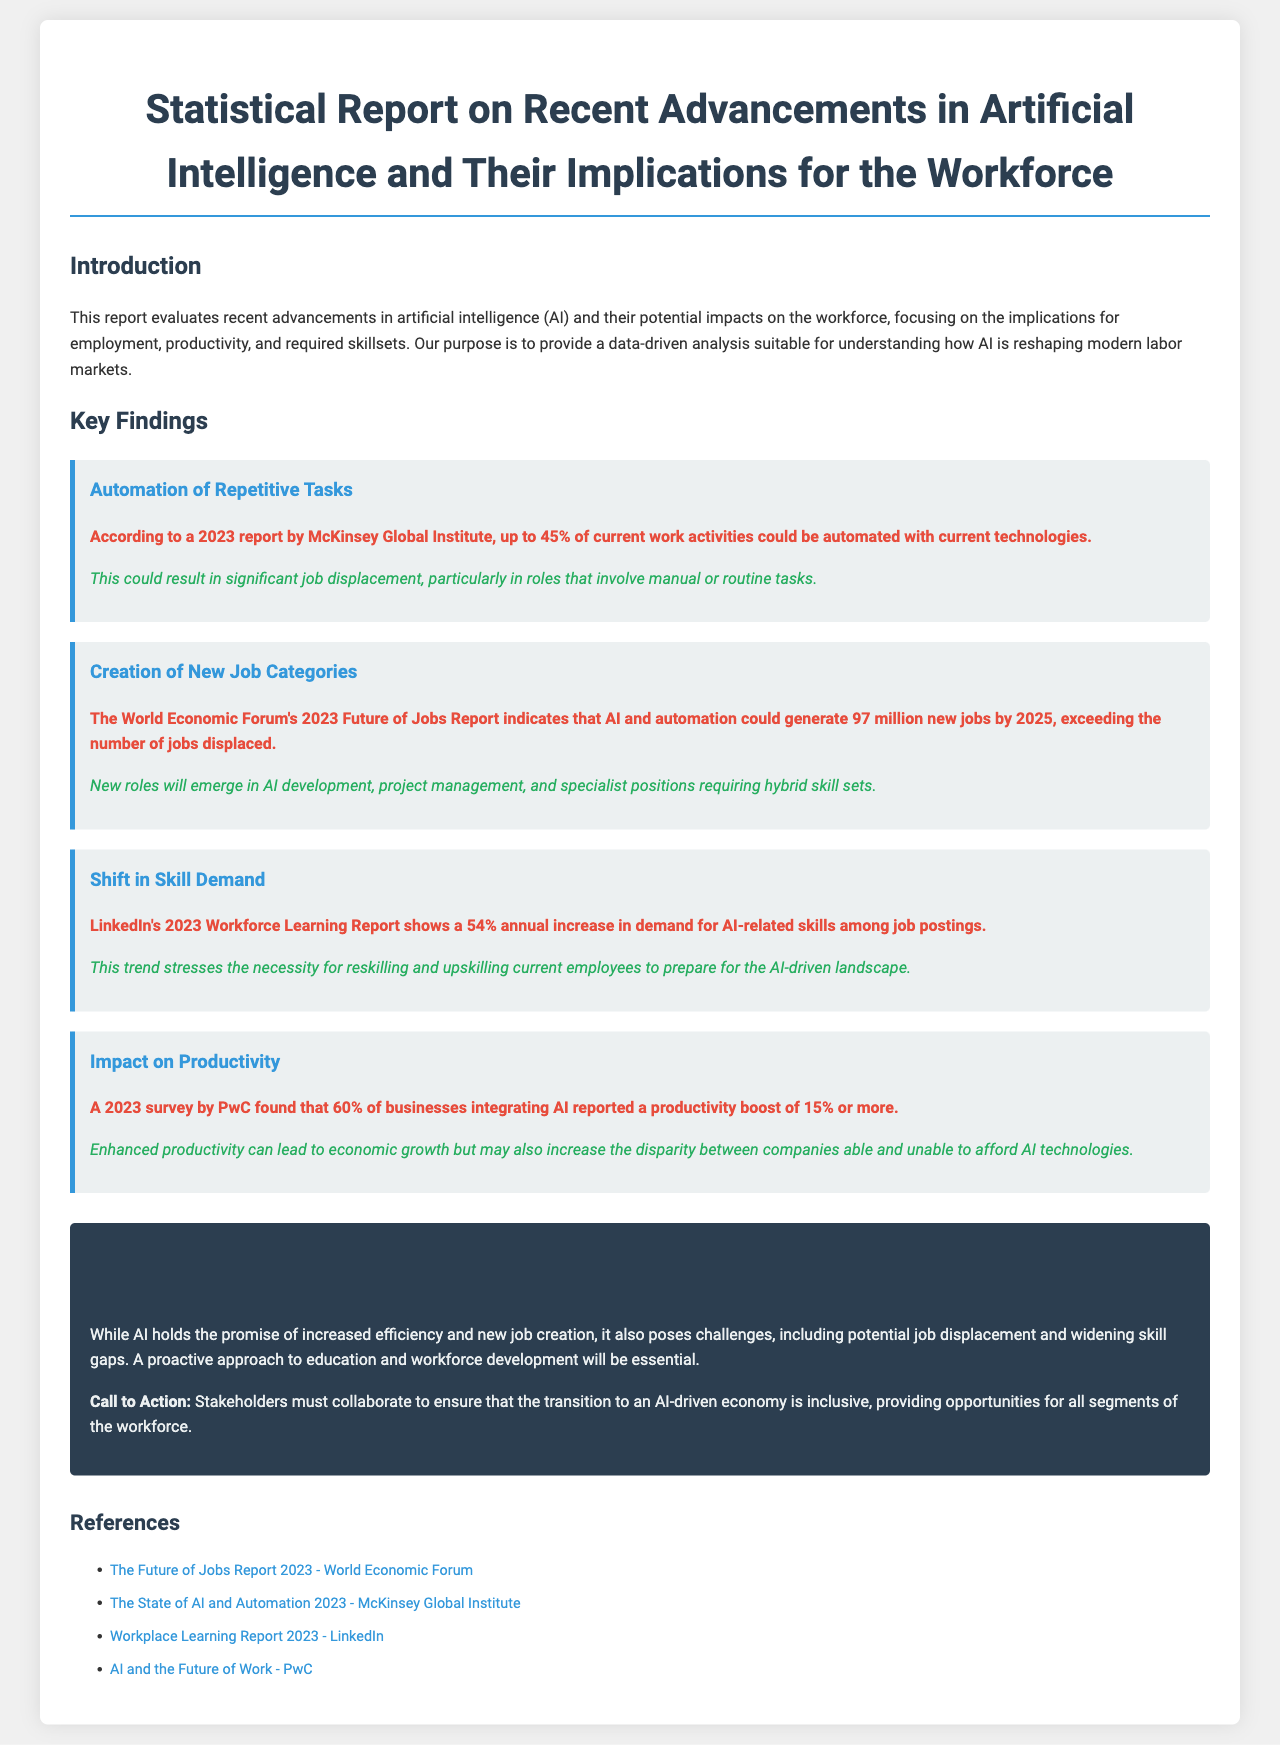What percentage of work activities could be automated? The report states that up to 45% of current work activities could be automated with current technologies according to McKinsey Global Institute.
Answer: 45% How many new jobs could AI and automation generate by 2025? According to the World Economic Forum's report, AI and automation could generate 97 million new jobs by 2025.
Answer: 97 million What is the annual increase in demand for AI-related skills among job postings? The LinkedIn's report shows a 54% annual increase in demand for AI-related skills among job postings.
Answer: 54% What percentage of businesses integrating AI reported a productivity boost of 15% or more? A 2023 survey by PwC found that 60% of businesses integrating AI reported this productivity boost.
Answer: 60% What is a potential challenge mentioned regarding AI's impact on the workforce? The report highlights job displacement as a significant challenge that may arise due to advancements in AI.
Answer: Job displacement What is the color of the container background in the report? The report's container background is styled with a white background color according to the CSS.
Answer: White What should stakeholders do to ensure an inclusive transition to an AI-driven economy? The report calls for collaboration among stakeholders to ensure inclusive opportunities during the transition.
Answer: Collaborate Which report outlines the future of jobs according to the document? The report references the "The Future of Jobs Report 2023 - World Economic Forum" as an important document in this context.
Answer: The Future of Jobs Report 2023 - World Economic Forum 